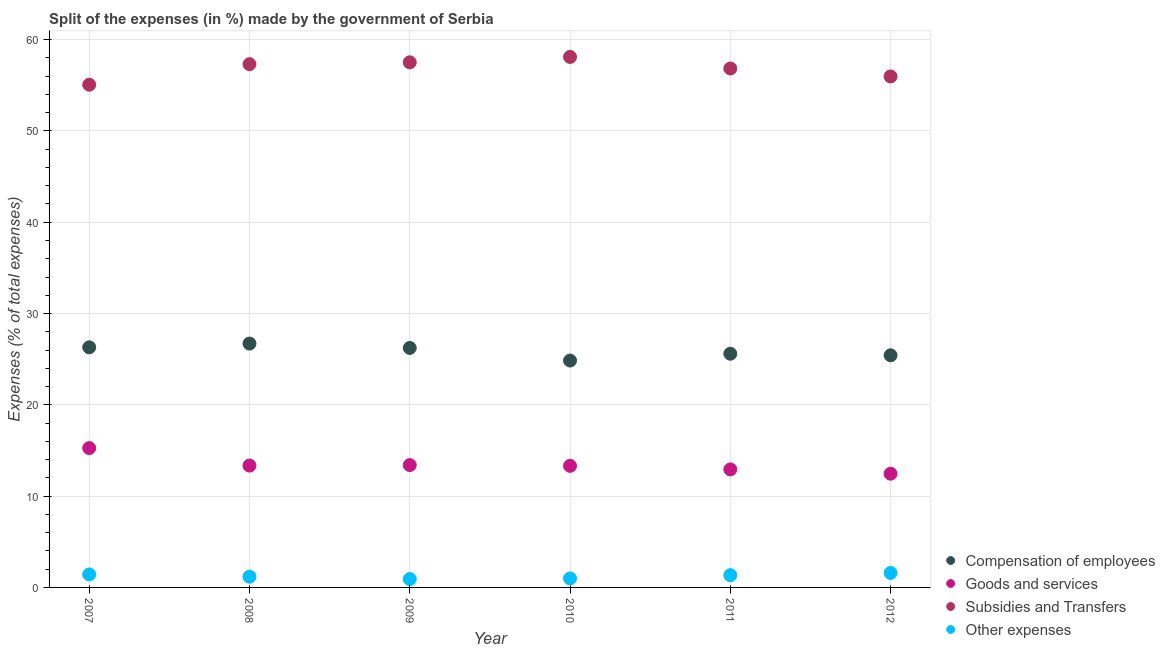How many different coloured dotlines are there?
Keep it short and to the point. 4. Is the number of dotlines equal to the number of legend labels?
Provide a short and direct response. Yes. What is the percentage of amount spent on subsidies in 2010?
Provide a short and direct response. 58.11. Across all years, what is the maximum percentage of amount spent on compensation of employees?
Your answer should be compact. 26.71. Across all years, what is the minimum percentage of amount spent on goods and services?
Make the answer very short. 12.46. In which year was the percentage of amount spent on goods and services minimum?
Give a very brief answer. 2012. What is the total percentage of amount spent on subsidies in the graph?
Keep it short and to the point. 340.81. What is the difference between the percentage of amount spent on subsidies in 2008 and that in 2011?
Your answer should be very brief. 0.48. What is the difference between the percentage of amount spent on subsidies in 2010 and the percentage of amount spent on goods and services in 2009?
Your response must be concise. 44.7. What is the average percentage of amount spent on subsidies per year?
Your answer should be compact. 56.8. In the year 2012, what is the difference between the percentage of amount spent on compensation of employees and percentage of amount spent on goods and services?
Ensure brevity in your answer.  12.97. In how many years, is the percentage of amount spent on goods and services greater than 26 %?
Keep it short and to the point. 0. What is the ratio of the percentage of amount spent on other expenses in 2009 to that in 2010?
Offer a very short reply. 0.93. Is the difference between the percentage of amount spent on compensation of employees in 2009 and 2012 greater than the difference between the percentage of amount spent on goods and services in 2009 and 2012?
Your answer should be compact. No. What is the difference between the highest and the second highest percentage of amount spent on other expenses?
Offer a terse response. 0.16. What is the difference between the highest and the lowest percentage of amount spent on compensation of employees?
Make the answer very short. 1.86. In how many years, is the percentage of amount spent on compensation of employees greater than the average percentage of amount spent on compensation of employees taken over all years?
Offer a terse response. 3. Is it the case that in every year, the sum of the percentage of amount spent on other expenses and percentage of amount spent on subsidies is greater than the sum of percentage of amount spent on goods and services and percentage of amount spent on compensation of employees?
Your answer should be very brief. Yes. Is it the case that in every year, the sum of the percentage of amount spent on compensation of employees and percentage of amount spent on goods and services is greater than the percentage of amount spent on subsidies?
Offer a very short reply. No. Is the percentage of amount spent on subsidies strictly greater than the percentage of amount spent on other expenses over the years?
Offer a terse response. Yes. Is the percentage of amount spent on compensation of employees strictly less than the percentage of amount spent on subsidies over the years?
Your answer should be very brief. Yes. How many years are there in the graph?
Offer a terse response. 6. What is the difference between two consecutive major ticks on the Y-axis?
Give a very brief answer. 10. Are the values on the major ticks of Y-axis written in scientific E-notation?
Ensure brevity in your answer.  No. Where does the legend appear in the graph?
Make the answer very short. Bottom right. How many legend labels are there?
Keep it short and to the point. 4. What is the title of the graph?
Your answer should be very brief. Split of the expenses (in %) made by the government of Serbia. What is the label or title of the X-axis?
Offer a very short reply. Year. What is the label or title of the Y-axis?
Make the answer very short. Expenses (% of total expenses). What is the Expenses (% of total expenses) of Compensation of employees in 2007?
Provide a short and direct response. 26.3. What is the Expenses (% of total expenses) in Goods and services in 2007?
Give a very brief answer. 15.26. What is the Expenses (% of total expenses) in Subsidies and Transfers in 2007?
Give a very brief answer. 55.06. What is the Expenses (% of total expenses) in Other expenses in 2007?
Keep it short and to the point. 1.42. What is the Expenses (% of total expenses) in Compensation of employees in 2008?
Your response must be concise. 26.71. What is the Expenses (% of total expenses) of Goods and services in 2008?
Give a very brief answer. 13.35. What is the Expenses (% of total expenses) of Subsidies and Transfers in 2008?
Give a very brief answer. 57.32. What is the Expenses (% of total expenses) in Other expenses in 2008?
Ensure brevity in your answer.  1.18. What is the Expenses (% of total expenses) in Compensation of employees in 2009?
Ensure brevity in your answer.  26.23. What is the Expenses (% of total expenses) in Goods and services in 2009?
Your answer should be very brief. 13.4. What is the Expenses (% of total expenses) of Subsidies and Transfers in 2009?
Keep it short and to the point. 57.52. What is the Expenses (% of total expenses) in Other expenses in 2009?
Make the answer very short. 0.92. What is the Expenses (% of total expenses) of Compensation of employees in 2010?
Keep it short and to the point. 24.85. What is the Expenses (% of total expenses) in Goods and services in 2010?
Your response must be concise. 13.32. What is the Expenses (% of total expenses) in Subsidies and Transfers in 2010?
Your response must be concise. 58.11. What is the Expenses (% of total expenses) in Other expenses in 2010?
Offer a very short reply. 0.99. What is the Expenses (% of total expenses) of Compensation of employees in 2011?
Make the answer very short. 25.6. What is the Expenses (% of total expenses) in Goods and services in 2011?
Your answer should be compact. 12.93. What is the Expenses (% of total expenses) in Subsidies and Transfers in 2011?
Keep it short and to the point. 56.84. What is the Expenses (% of total expenses) of Other expenses in 2011?
Provide a succinct answer. 1.34. What is the Expenses (% of total expenses) in Compensation of employees in 2012?
Your answer should be very brief. 25.43. What is the Expenses (% of total expenses) of Goods and services in 2012?
Keep it short and to the point. 12.46. What is the Expenses (% of total expenses) in Subsidies and Transfers in 2012?
Offer a terse response. 55.97. What is the Expenses (% of total expenses) in Other expenses in 2012?
Give a very brief answer. 1.59. Across all years, what is the maximum Expenses (% of total expenses) of Compensation of employees?
Your response must be concise. 26.71. Across all years, what is the maximum Expenses (% of total expenses) in Goods and services?
Your answer should be very brief. 15.26. Across all years, what is the maximum Expenses (% of total expenses) in Subsidies and Transfers?
Your answer should be very brief. 58.11. Across all years, what is the maximum Expenses (% of total expenses) of Other expenses?
Provide a short and direct response. 1.59. Across all years, what is the minimum Expenses (% of total expenses) in Compensation of employees?
Give a very brief answer. 24.85. Across all years, what is the minimum Expenses (% of total expenses) in Goods and services?
Offer a terse response. 12.46. Across all years, what is the minimum Expenses (% of total expenses) in Subsidies and Transfers?
Offer a terse response. 55.06. Across all years, what is the minimum Expenses (% of total expenses) of Other expenses?
Offer a very short reply. 0.92. What is the total Expenses (% of total expenses) of Compensation of employees in the graph?
Provide a short and direct response. 155.11. What is the total Expenses (% of total expenses) of Goods and services in the graph?
Your answer should be compact. 80.71. What is the total Expenses (% of total expenses) in Subsidies and Transfers in the graph?
Make the answer very short. 340.81. What is the total Expenses (% of total expenses) of Other expenses in the graph?
Provide a succinct answer. 7.43. What is the difference between the Expenses (% of total expenses) of Compensation of employees in 2007 and that in 2008?
Your answer should be compact. -0.41. What is the difference between the Expenses (% of total expenses) of Goods and services in 2007 and that in 2008?
Your answer should be compact. 1.92. What is the difference between the Expenses (% of total expenses) of Subsidies and Transfers in 2007 and that in 2008?
Offer a very short reply. -2.25. What is the difference between the Expenses (% of total expenses) of Other expenses in 2007 and that in 2008?
Give a very brief answer. 0.25. What is the difference between the Expenses (% of total expenses) of Compensation of employees in 2007 and that in 2009?
Provide a succinct answer. 0.07. What is the difference between the Expenses (% of total expenses) of Goods and services in 2007 and that in 2009?
Provide a short and direct response. 1.86. What is the difference between the Expenses (% of total expenses) of Subsidies and Transfers in 2007 and that in 2009?
Give a very brief answer. -2.45. What is the difference between the Expenses (% of total expenses) in Other expenses in 2007 and that in 2009?
Give a very brief answer. 0.5. What is the difference between the Expenses (% of total expenses) in Compensation of employees in 2007 and that in 2010?
Offer a terse response. 1.45. What is the difference between the Expenses (% of total expenses) of Goods and services in 2007 and that in 2010?
Your response must be concise. 1.94. What is the difference between the Expenses (% of total expenses) in Subsidies and Transfers in 2007 and that in 2010?
Your answer should be very brief. -3.04. What is the difference between the Expenses (% of total expenses) in Other expenses in 2007 and that in 2010?
Your response must be concise. 0.44. What is the difference between the Expenses (% of total expenses) of Compensation of employees in 2007 and that in 2011?
Offer a very short reply. 0.7. What is the difference between the Expenses (% of total expenses) of Goods and services in 2007 and that in 2011?
Your answer should be compact. 2.33. What is the difference between the Expenses (% of total expenses) in Subsidies and Transfers in 2007 and that in 2011?
Your response must be concise. -1.78. What is the difference between the Expenses (% of total expenses) of Other expenses in 2007 and that in 2011?
Ensure brevity in your answer.  0.08. What is the difference between the Expenses (% of total expenses) of Compensation of employees in 2007 and that in 2012?
Offer a very short reply. 0.87. What is the difference between the Expenses (% of total expenses) of Goods and services in 2007 and that in 2012?
Offer a terse response. 2.81. What is the difference between the Expenses (% of total expenses) of Subsidies and Transfers in 2007 and that in 2012?
Provide a succinct answer. -0.91. What is the difference between the Expenses (% of total expenses) in Other expenses in 2007 and that in 2012?
Your answer should be very brief. -0.16. What is the difference between the Expenses (% of total expenses) in Compensation of employees in 2008 and that in 2009?
Ensure brevity in your answer.  0.48. What is the difference between the Expenses (% of total expenses) in Goods and services in 2008 and that in 2009?
Keep it short and to the point. -0.06. What is the difference between the Expenses (% of total expenses) of Subsidies and Transfers in 2008 and that in 2009?
Make the answer very short. -0.2. What is the difference between the Expenses (% of total expenses) of Other expenses in 2008 and that in 2009?
Ensure brevity in your answer.  0.25. What is the difference between the Expenses (% of total expenses) in Compensation of employees in 2008 and that in 2010?
Make the answer very short. 1.86. What is the difference between the Expenses (% of total expenses) in Goods and services in 2008 and that in 2010?
Make the answer very short. 0.03. What is the difference between the Expenses (% of total expenses) of Subsidies and Transfers in 2008 and that in 2010?
Give a very brief answer. -0.79. What is the difference between the Expenses (% of total expenses) in Other expenses in 2008 and that in 2010?
Make the answer very short. 0.19. What is the difference between the Expenses (% of total expenses) in Compensation of employees in 2008 and that in 2011?
Provide a succinct answer. 1.11. What is the difference between the Expenses (% of total expenses) in Goods and services in 2008 and that in 2011?
Your answer should be compact. 0.42. What is the difference between the Expenses (% of total expenses) in Subsidies and Transfers in 2008 and that in 2011?
Provide a succinct answer. 0.48. What is the difference between the Expenses (% of total expenses) in Other expenses in 2008 and that in 2011?
Provide a short and direct response. -0.17. What is the difference between the Expenses (% of total expenses) of Compensation of employees in 2008 and that in 2012?
Your response must be concise. 1.28. What is the difference between the Expenses (% of total expenses) in Goods and services in 2008 and that in 2012?
Provide a succinct answer. 0.89. What is the difference between the Expenses (% of total expenses) of Subsidies and Transfers in 2008 and that in 2012?
Provide a succinct answer. 1.35. What is the difference between the Expenses (% of total expenses) of Other expenses in 2008 and that in 2012?
Your answer should be compact. -0.41. What is the difference between the Expenses (% of total expenses) of Compensation of employees in 2009 and that in 2010?
Give a very brief answer. 1.38. What is the difference between the Expenses (% of total expenses) of Goods and services in 2009 and that in 2010?
Ensure brevity in your answer.  0.08. What is the difference between the Expenses (% of total expenses) in Subsidies and Transfers in 2009 and that in 2010?
Make the answer very short. -0.59. What is the difference between the Expenses (% of total expenses) in Other expenses in 2009 and that in 2010?
Give a very brief answer. -0.07. What is the difference between the Expenses (% of total expenses) of Compensation of employees in 2009 and that in 2011?
Your answer should be very brief. 0.64. What is the difference between the Expenses (% of total expenses) in Goods and services in 2009 and that in 2011?
Your response must be concise. 0.47. What is the difference between the Expenses (% of total expenses) of Subsidies and Transfers in 2009 and that in 2011?
Ensure brevity in your answer.  0.68. What is the difference between the Expenses (% of total expenses) of Other expenses in 2009 and that in 2011?
Your response must be concise. -0.42. What is the difference between the Expenses (% of total expenses) of Compensation of employees in 2009 and that in 2012?
Ensure brevity in your answer.  0.81. What is the difference between the Expenses (% of total expenses) of Goods and services in 2009 and that in 2012?
Provide a short and direct response. 0.95. What is the difference between the Expenses (% of total expenses) in Subsidies and Transfers in 2009 and that in 2012?
Your response must be concise. 1.55. What is the difference between the Expenses (% of total expenses) of Other expenses in 2009 and that in 2012?
Your response must be concise. -0.67. What is the difference between the Expenses (% of total expenses) in Compensation of employees in 2010 and that in 2011?
Your answer should be very brief. -0.75. What is the difference between the Expenses (% of total expenses) in Goods and services in 2010 and that in 2011?
Ensure brevity in your answer.  0.39. What is the difference between the Expenses (% of total expenses) of Subsidies and Transfers in 2010 and that in 2011?
Your response must be concise. 1.27. What is the difference between the Expenses (% of total expenses) of Other expenses in 2010 and that in 2011?
Give a very brief answer. -0.36. What is the difference between the Expenses (% of total expenses) in Compensation of employees in 2010 and that in 2012?
Keep it short and to the point. -0.58. What is the difference between the Expenses (% of total expenses) of Goods and services in 2010 and that in 2012?
Offer a very short reply. 0.86. What is the difference between the Expenses (% of total expenses) of Subsidies and Transfers in 2010 and that in 2012?
Offer a very short reply. 2.14. What is the difference between the Expenses (% of total expenses) in Compensation of employees in 2011 and that in 2012?
Your answer should be very brief. 0.17. What is the difference between the Expenses (% of total expenses) of Goods and services in 2011 and that in 2012?
Provide a succinct answer. 0.47. What is the difference between the Expenses (% of total expenses) in Subsidies and Transfers in 2011 and that in 2012?
Make the answer very short. 0.87. What is the difference between the Expenses (% of total expenses) of Other expenses in 2011 and that in 2012?
Provide a succinct answer. -0.24. What is the difference between the Expenses (% of total expenses) in Compensation of employees in 2007 and the Expenses (% of total expenses) in Goods and services in 2008?
Keep it short and to the point. 12.95. What is the difference between the Expenses (% of total expenses) in Compensation of employees in 2007 and the Expenses (% of total expenses) in Subsidies and Transfers in 2008?
Provide a short and direct response. -31.02. What is the difference between the Expenses (% of total expenses) of Compensation of employees in 2007 and the Expenses (% of total expenses) of Other expenses in 2008?
Give a very brief answer. 25.12. What is the difference between the Expenses (% of total expenses) of Goods and services in 2007 and the Expenses (% of total expenses) of Subsidies and Transfers in 2008?
Make the answer very short. -42.05. What is the difference between the Expenses (% of total expenses) in Goods and services in 2007 and the Expenses (% of total expenses) in Other expenses in 2008?
Your answer should be very brief. 14.09. What is the difference between the Expenses (% of total expenses) of Subsidies and Transfers in 2007 and the Expenses (% of total expenses) of Other expenses in 2008?
Keep it short and to the point. 53.89. What is the difference between the Expenses (% of total expenses) of Compensation of employees in 2007 and the Expenses (% of total expenses) of Goods and services in 2009?
Ensure brevity in your answer.  12.9. What is the difference between the Expenses (% of total expenses) in Compensation of employees in 2007 and the Expenses (% of total expenses) in Subsidies and Transfers in 2009?
Make the answer very short. -31.22. What is the difference between the Expenses (% of total expenses) of Compensation of employees in 2007 and the Expenses (% of total expenses) of Other expenses in 2009?
Make the answer very short. 25.38. What is the difference between the Expenses (% of total expenses) in Goods and services in 2007 and the Expenses (% of total expenses) in Subsidies and Transfers in 2009?
Offer a very short reply. -42.25. What is the difference between the Expenses (% of total expenses) of Goods and services in 2007 and the Expenses (% of total expenses) of Other expenses in 2009?
Offer a terse response. 14.34. What is the difference between the Expenses (% of total expenses) of Subsidies and Transfers in 2007 and the Expenses (% of total expenses) of Other expenses in 2009?
Offer a terse response. 54.14. What is the difference between the Expenses (% of total expenses) in Compensation of employees in 2007 and the Expenses (% of total expenses) in Goods and services in 2010?
Offer a terse response. 12.98. What is the difference between the Expenses (% of total expenses) of Compensation of employees in 2007 and the Expenses (% of total expenses) of Subsidies and Transfers in 2010?
Provide a succinct answer. -31.81. What is the difference between the Expenses (% of total expenses) in Compensation of employees in 2007 and the Expenses (% of total expenses) in Other expenses in 2010?
Offer a terse response. 25.31. What is the difference between the Expenses (% of total expenses) of Goods and services in 2007 and the Expenses (% of total expenses) of Subsidies and Transfers in 2010?
Provide a succinct answer. -42.84. What is the difference between the Expenses (% of total expenses) in Goods and services in 2007 and the Expenses (% of total expenses) in Other expenses in 2010?
Make the answer very short. 14.28. What is the difference between the Expenses (% of total expenses) of Subsidies and Transfers in 2007 and the Expenses (% of total expenses) of Other expenses in 2010?
Make the answer very short. 54.08. What is the difference between the Expenses (% of total expenses) of Compensation of employees in 2007 and the Expenses (% of total expenses) of Goods and services in 2011?
Provide a succinct answer. 13.37. What is the difference between the Expenses (% of total expenses) in Compensation of employees in 2007 and the Expenses (% of total expenses) in Subsidies and Transfers in 2011?
Your answer should be compact. -30.54. What is the difference between the Expenses (% of total expenses) of Compensation of employees in 2007 and the Expenses (% of total expenses) of Other expenses in 2011?
Give a very brief answer. 24.96. What is the difference between the Expenses (% of total expenses) of Goods and services in 2007 and the Expenses (% of total expenses) of Subsidies and Transfers in 2011?
Keep it short and to the point. -41.58. What is the difference between the Expenses (% of total expenses) of Goods and services in 2007 and the Expenses (% of total expenses) of Other expenses in 2011?
Your answer should be very brief. 13.92. What is the difference between the Expenses (% of total expenses) of Subsidies and Transfers in 2007 and the Expenses (% of total expenses) of Other expenses in 2011?
Offer a terse response. 53.72. What is the difference between the Expenses (% of total expenses) of Compensation of employees in 2007 and the Expenses (% of total expenses) of Goods and services in 2012?
Your answer should be very brief. 13.84. What is the difference between the Expenses (% of total expenses) of Compensation of employees in 2007 and the Expenses (% of total expenses) of Subsidies and Transfers in 2012?
Make the answer very short. -29.67. What is the difference between the Expenses (% of total expenses) in Compensation of employees in 2007 and the Expenses (% of total expenses) in Other expenses in 2012?
Provide a succinct answer. 24.71. What is the difference between the Expenses (% of total expenses) of Goods and services in 2007 and the Expenses (% of total expenses) of Subsidies and Transfers in 2012?
Offer a very short reply. -40.71. What is the difference between the Expenses (% of total expenses) in Goods and services in 2007 and the Expenses (% of total expenses) in Other expenses in 2012?
Offer a very short reply. 13.68. What is the difference between the Expenses (% of total expenses) in Subsidies and Transfers in 2007 and the Expenses (% of total expenses) in Other expenses in 2012?
Offer a very short reply. 53.48. What is the difference between the Expenses (% of total expenses) in Compensation of employees in 2008 and the Expenses (% of total expenses) in Goods and services in 2009?
Offer a very short reply. 13.31. What is the difference between the Expenses (% of total expenses) of Compensation of employees in 2008 and the Expenses (% of total expenses) of Subsidies and Transfers in 2009?
Your answer should be very brief. -30.81. What is the difference between the Expenses (% of total expenses) in Compensation of employees in 2008 and the Expenses (% of total expenses) in Other expenses in 2009?
Provide a short and direct response. 25.79. What is the difference between the Expenses (% of total expenses) of Goods and services in 2008 and the Expenses (% of total expenses) of Subsidies and Transfers in 2009?
Offer a terse response. -44.17. What is the difference between the Expenses (% of total expenses) of Goods and services in 2008 and the Expenses (% of total expenses) of Other expenses in 2009?
Your answer should be very brief. 12.43. What is the difference between the Expenses (% of total expenses) of Subsidies and Transfers in 2008 and the Expenses (% of total expenses) of Other expenses in 2009?
Keep it short and to the point. 56.4. What is the difference between the Expenses (% of total expenses) in Compensation of employees in 2008 and the Expenses (% of total expenses) in Goods and services in 2010?
Offer a terse response. 13.39. What is the difference between the Expenses (% of total expenses) in Compensation of employees in 2008 and the Expenses (% of total expenses) in Subsidies and Transfers in 2010?
Your answer should be very brief. -31.4. What is the difference between the Expenses (% of total expenses) in Compensation of employees in 2008 and the Expenses (% of total expenses) in Other expenses in 2010?
Ensure brevity in your answer.  25.72. What is the difference between the Expenses (% of total expenses) of Goods and services in 2008 and the Expenses (% of total expenses) of Subsidies and Transfers in 2010?
Your answer should be very brief. -44.76. What is the difference between the Expenses (% of total expenses) of Goods and services in 2008 and the Expenses (% of total expenses) of Other expenses in 2010?
Offer a terse response. 12.36. What is the difference between the Expenses (% of total expenses) of Subsidies and Transfers in 2008 and the Expenses (% of total expenses) of Other expenses in 2010?
Your answer should be very brief. 56.33. What is the difference between the Expenses (% of total expenses) of Compensation of employees in 2008 and the Expenses (% of total expenses) of Goods and services in 2011?
Offer a very short reply. 13.78. What is the difference between the Expenses (% of total expenses) of Compensation of employees in 2008 and the Expenses (% of total expenses) of Subsidies and Transfers in 2011?
Your response must be concise. -30.13. What is the difference between the Expenses (% of total expenses) in Compensation of employees in 2008 and the Expenses (% of total expenses) in Other expenses in 2011?
Provide a succinct answer. 25.37. What is the difference between the Expenses (% of total expenses) in Goods and services in 2008 and the Expenses (% of total expenses) in Subsidies and Transfers in 2011?
Provide a succinct answer. -43.49. What is the difference between the Expenses (% of total expenses) in Goods and services in 2008 and the Expenses (% of total expenses) in Other expenses in 2011?
Your answer should be compact. 12. What is the difference between the Expenses (% of total expenses) in Subsidies and Transfers in 2008 and the Expenses (% of total expenses) in Other expenses in 2011?
Make the answer very short. 55.97. What is the difference between the Expenses (% of total expenses) of Compensation of employees in 2008 and the Expenses (% of total expenses) of Goods and services in 2012?
Provide a succinct answer. 14.25. What is the difference between the Expenses (% of total expenses) of Compensation of employees in 2008 and the Expenses (% of total expenses) of Subsidies and Transfers in 2012?
Your response must be concise. -29.26. What is the difference between the Expenses (% of total expenses) in Compensation of employees in 2008 and the Expenses (% of total expenses) in Other expenses in 2012?
Make the answer very short. 25.12. What is the difference between the Expenses (% of total expenses) in Goods and services in 2008 and the Expenses (% of total expenses) in Subsidies and Transfers in 2012?
Ensure brevity in your answer.  -42.62. What is the difference between the Expenses (% of total expenses) in Goods and services in 2008 and the Expenses (% of total expenses) in Other expenses in 2012?
Your response must be concise. 11.76. What is the difference between the Expenses (% of total expenses) of Subsidies and Transfers in 2008 and the Expenses (% of total expenses) of Other expenses in 2012?
Your response must be concise. 55.73. What is the difference between the Expenses (% of total expenses) in Compensation of employees in 2009 and the Expenses (% of total expenses) in Goods and services in 2010?
Give a very brief answer. 12.91. What is the difference between the Expenses (% of total expenses) in Compensation of employees in 2009 and the Expenses (% of total expenses) in Subsidies and Transfers in 2010?
Your response must be concise. -31.87. What is the difference between the Expenses (% of total expenses) in Compensation of employees in 2009 and the Expenses (% of total expenses) in Other expenses in 2010?
Provide a short and direct response. 25.25. What is the difference between the Expenses (% of total expenses) in Goods and services in 2009 and the Expenses (% of total expenses) in Subsidies and Transfers in 2010?
Give a very brief answer. -44.7. What is the difference between the Expenses (% of total expenses) in Goods and services in 2009 and the Expenses (% of total expenses) in Other expenses in 2010?
Ensure brevity in your answer.  12.42. What is the difference between the Expenses (% of total expenses) of Subsidies and Transfers in 2009 and the Expenses (% of total expenses) of Other expenses in 2010?
Keep it short and to the point. 56.53. What is the difference between the Expenses (% of total expenses) of Compensation of employees in 2009 and the Expenses (% of total expenses) of Goods and services in 2011?
Give a very brief answer. 13.3. What is the difference between the Expenses (% of total expenses) in Compensation of employees in 2009 and the Expenses (% of total expenses) in Subsidies and Transfers in 2011?
Your answer should be very brief. -30.61. What is the difference between the Expenses (% of total expenses) in Compensation of employees in 2009 and the Expenses (% of total expenses) in Other expenses in 2011?
Ensure brevity in your answer.  24.89. What is the difference between the Expenses (% of total expenses) in Goods and services in 2009 and the Expenses (% of total expenses) in Subsidies and Transfers in 2011?
Keep it short and to the point. -43.44. What is the difference between the Expenses (% of total expenses) of Goods and services in 2009 and the Expenses (% of total expenses) of Other expenses in 2011?
Offer a very short reply. 12.06. What is the difference between the Expenses (% of total expenses) of Subsidies and Transfers in 2009 and the Expenses (% of total expenses) of Other expenses in 2011?
Provide a succinct answer. 56.17. What is the difference between the Expenses (% of total expenses) in Compensation of employees in 2009 and the Expenses (% of total expenses) in Goods and services in 2012?
Keep it short and to the point. 13.78. What is the difference between the Expenses (% of total expenses) in Compensation of employees in 2009 and the Expenses (% of total expenses) in Subsidies and Transfers in 2012?
Your answer should be compact. -29.74. What is the difference between the Expenses (% of total expenses) of Compensation of employees in 2009 and the Expenses (% of total expenses) of Other expenses in 2012?
Your answer should be very brief. 24.65. What is the difference between the Expenses (% of total expenses) in Goods and services in 2009 and the Expenses (% of total expenses) in Subsidies and Transfers in 2012?
Provide a short and direct response. -42.57. What is the difference between the Expenses (% of total expenses) of Goods and services in 2009 and the Expenses (% of total expenses) of Other expenses in 2012?
Your answer should be very brief. 11.82. What is the difference between the Expenses (% of total expenses) in Subsidies and Transfers in 2009 and the Expenses (% of total expenses) in Other expenses in 2012?
Your answer should be compact. 55.93. What is the difference between the Expenses (% of total expenses) in Compensation of employees in 2010 and the Expenses (% of total expenses) in Goods and services in 2011?
Your answer should be very brief. 11.92. What is the difference between the Expenses (% of total expenses) of Compensation of employees in 2010 and the Expenses (% of total expenses) of Subsidies and Transfers in 2011?
Give a very brief answer. -31.99. What is the difference between the Expenses (% of total expenses) of Compensation of employees in 2010 and the Expenses (% of total expenses) of Other expenses in 2011?
Make the answer very short. 23.51. What is the difference between the Expenses (% of total expenses) of Goods and services in 2010 and the Expenses (% of total expenses) of Subsidies and Transfers in 2011?
Give a very brief answer. -43.52. What is the difference between the Expenses (% of total expenses) of Goods and services in 2010 and the Expenses (% of total expenses) of Other expenses in 2011?
Your answer should be compact. 11.98. What is the difference between the Expenses (% of total expenses) of Subsidies and Transfers in 2010 and the Expenses (% of total expenses) of Other expenses in 2011?
Give a very brief answer. 56.76. What is the difference between the Expenses (% of total expenses) in Compensation of employees in 2010 and the Expenses (% of total expenses) in Goods and services in 2012?
Your answer should be compact. 12.39. What is the difference between the Expenses (% of total expenses) in Compensation of employees in 2010 and the Expenses (% of total expenses) in Subsidies and Transfers in 2012?
Give a very brief answer. -31.12. What is the difference between the Expenses (% of total expenses) in Compensation of employees in 2010 and the Expenses (% of total expenses) in Other expenses in 2012?
Provide a short and direct response. 23.26. What is the difference between the Expenses (% of total expenses) of Goods and services in 2010 and the Expenses (% of total expenses) of Subsidies and Transfers in 2012?
Provide a succinct answer. -42.65. What is the difference between the Expenses (% of total expenses) in Goods and services in 2010 and the Expenses (% of total expenses) in Other expenses in 2012?
Ensure brevity in your answer.  11.73. What is the difference between the Expenses (% of total expenses) of Subsidies and Transfers in 2010 and the Expenses (% of total expenses) of Other expenses in 2012?
Your answer should be compact. 56.52. What is the difference between the Expenses (% of total expenses) in Compensation of employees in 2011 and the Expenses (% of total expenses) in Goods and services in 2012?
Your response must be concise. 13.14. What is the difference between the Expenses (% of total expenses) of Compensation of employees in 2011 and the Expenses (% of total expenses) of Subsidies and Transfers in 2012?
Make the answer very short. -30.37. What is the difference between the Expenses (% of total expenses) of Compensation of employees in 2011 and the Expenses (% of total expenses) of Other expenses in 2012?
Give a very brief answer. 24.01. What is the difference between the Expenses (% of total expenses) of Goods and services in 2011 and the Expenses (% of total expenses) of Subsidies and Transfers in 2012?
Provide a succinct answer. -43.04. What is the difference between the Expenses (% of total expenses) in Goods and services in 2011 and the Expenses (% of total expenses) in Other expenses in 2012?
Your answer should be compact. 11.34. What is the difference between the Expenses (% of total expenses) in Subsidies and Transfers in 2011 and the Expenses (% of total expenses) in Other expenses in 2012?
Give a very brief answer. 55.25. What is the average Expenses (% of total expenses) in Compensation of employees per year?
Your answer should be very brief. 25.85. What is the average Expenses (% of total expenses) of Goods and services per year?
Your answer should be very brief. 13.45. What is the average Expenses (% of total expenses) in Subsidies and Transfers per year?
Your answer should be compact. 56.8. What is the average Expenses (% of total expenses) in Other expenses per year?
Your answer should be very brief. 1.24. In the year 2007, what is the difference between the Expenses (% of total expenses) in Compensation of employees and Expenses (% of total expenses) in Goods and services?
Your response must be concise. 11.04. In the year 2007, what is the difference between the Expenses (% of total expenses) of Compensation of employees and Expenses (% of total expenses) of Subsidies and Transfers?
Give a very brief answer. -28.76. In the year 2007, what is the difference between the Expenses (% of total expenses) of Compensation of employees and Expenses (% of total expenses) of Other expenses?
Make the answer very short. 24.88. In the year 2007, what is the difference between the Expenses (% of total expenses) in Goods and services and Expenses (% of total expenses) in Subsidies and Transfers?
Give a very brief answer. -39.8. In the year 2007, what is the difference between the Expenses (% of total expenses) in Goods and services and Expenses (% of total expenses) in Other expenses?
Ensure brevity in your answer.  13.84. In the year 2007, what is the difference between the Expenses (% of total expenses) in Subsidies and Transfers and Expenses (% of total expenses) in Other expenses?
Your response must be concise. 53.64. In the year 2008, what is the difference between the Expenses (% of total expenses) in Compensation of employees and Expenses (% of total expenses) in Goods and services?
Your response must be concise. 13.36. In the year 2008, what is the difference between the Expenses (% of total expenses) of Compensation of employees and Expenses (% of total expenses) of Subsidies and Transfers?
Keep it short and to the point. -30.61. In the year 2008, what is the difference between the Expenses (% of total expenses) in Compensation of employees and Expenses (% of total expenses) in Other expenses?
Keep it short and to the point. 25.53. In the year 2008, what is the difference between the Expenses (% of total expenses) in Goods and services and Expenses (% of total expenses) in Subsidies and Transfers?
Make the answer very short. -43.97. In the year 2008, what is the difference between the Expenses (% of total expenses) in Goods and services and Expenses (% of total expenses) in Other expenses?
Make the answer very short. 12.17. In the year 2008, what is the difference between the Expenses (% of total expenses) in Subsidies and Transfers and Expenses (% of total expenses) in Other expenses?
Your response must be concise. 56.14. In the year 2009, what is the difference between the Expenses (% of total expenses) in Compensation of employees and Expenses (% of total expenses) in Goods and services?
Offer a terse response. 12.83. In the year 2009, what is the difference between the Expenses (% of total expenses) in Compensation of employees and Expenses (% of total expenses) in Subsidies and Transfers?
Provide a succinct answer. -31.28. In the year 2009, what is the difference between the Expenses (% of total expenses) of Compensation of employees and Expenses (% of total expenses) of Other expenses?
Your answer should be very brief. 25.31. In the year 2009, what is the difference between the Expenses (% of total expenses) in Goods and services and Expenses (% of total expenses) in Subsidies and Transfers?
Provide a short and direct response. -44.11. In the year 2009, what is the difference between the Expenses (% of total expenses) in Goods and services and Expenses (% of total expenses) in Other expenses?
Ensure brevity in your answer.  12.48. In the year 2009, what is the difference between the Expenses (% of total expenses) of Subsidies and Transfers and Expenses (% of total expenses) of Other expenses?
Offer a very short reply. 56.59. In the year 2010, what is the difference between the Expenses (% of total expenses) in Compensation of employees and Expenses (% of total expenses) in Goods and services?
Ensure brevity in your answer.  11.53. In the year 2010, what is the difference between the Expenses (% of total expenses) in Compensation of employees and Expenses (% of total expenses) in Subsidies and Transfers?
Offer a very short reply. -33.26. In the year 2010, what is the difference between the Expenses (% of total expenses) of Compensation of employees and Expenses (% of total expenses) of Other expenses?
Give a very brief answer. 23.86. In the year 2010, what is the difference between the Expenses (% of total expenses) in Goods and services and Expenses (% of total expenses) in Subsidies and Transfers?
Keep it short and to the point. -44.79. In the year 2010, what is the difference between the Expenses (% of total expenses) of Goods and services and Expenses (% of total expenses) of Other expenses?
Provide a succinct answer. 12.33. In the year 2010, what is the difference between the Expenses (% of total expenses) of Subsidies and Transfers and Expenses (% of total expenses) of Other expenses?
Provide a short and direct response. 57.12. In the year 2011, what is the difference between the Expenses (% of total expenses) in Compensation of employees and Expenses (% of total expenses) in Goods and services?
Your answer should be very brief. 12.67. In the year 2011, what is the difference between the Expenses (% of total expenses) of Compensation of employees and Expenses (% of total expenses) of Subsidies and Transfers?
Your answer should be very brief. -31.24. In the year 2011, what is the difference between the Expenses (% of total expenses) of Compensation of employees and Expenses (% of total expenses) of Other expenses?
Keep it short and to the point. 24.25. In the year 2011, what is the difference between the Expenses (% of total expenses) in Goods and services and Expenses (% of total expenses) in Subsidies and Transfers?
Your response must be concise. -43.91. In the year 2011, what is the difference between the Expenses (% of total expenses) in Goods and services and Expenses (% of total expenses) in Other expenses?
Offer a terse response. 11.59. In the year 2011, what is the difference between the Expenses (% of total expenses) in Subsidies and Transfers and Expenses (% of total expenses) in Other expenses?
Ensure brevity in your answer.  55.5. In the year 2012, what is the difference between the Expenses (% of total expenses) of Compensation of employees and Expenses (% of total expenses) of Goods and services?
Keep it short and to the point. 12.97. In the year 2012, what is the difference between the Expenses (% of total expenses) in Compensation of employees and Expenses (% of total expenses) in Subsidies and Transfers?
Your response must be concise. -30.54. In the year 2012, what is the difference between the Expenses (% of total expenses) in Compensation of employees and Expenses (% of total expenses) in Other expenses?
Offer a terse response. 23.84. In the year 2012, what is the difference between the Expenses (% of total expenses) in Goods and services and Expenses (% of total expenses) in Subsidies and Transfers?
Ensure brevity in your answer.  -43.51. In the year 2012, what is the difference between the Expenses (% of total expenses) of Goods and services and Expenses (% of total expenses) of Other expenses?
Keep it short and to the point. 10.87. In the year 2012, what is the difference between the Expenses (% of total expenses) of Subsidies and Transfers and Expenses (% of total expenses) of Other expenses?
Offer a terse response. 54.38. What is the ratio of the Expenses (% of total expenses) in Compensation of employees in 2007 to that in 2008?
Your response must be concise. 0.98. What is the ratio of the Expenses (% of total expenses) of Goods and services in 2007 to that in 2008?
Your answer should be compact. 1.14. What is the ratio of the Expenses (% of total expenses) of Subsidies and Transfers in 2007 to that in 2008?
Your answer should be very brief. 0.96. What is the ratio of the Expenses (% of total expenses) in Other expenses in 2007 to that in 2008?
Your answer should be compact. 1.21. What is the ratio of the Expenses (% of total expenses) of Goods and services in 2007 to that in 2009?
Ensure brevity in your answer.  1.14. What is the ratio of the Expenses (% of total expenses) of Subsidies and Transfers in 2007 to that in 2009?
Provide a succinct answer. 0.96. What is the ratio of the Expenses (% of total expenses) in Other expenses in 2007 to that in 2009?
Provide a succinct answer. 1.54. What is the ratio of the Expenses (% of total expenses) in Compensation of employees in 2007 to that in 2010?
Offer a terse response. 1.06. What is the ratio of the Expenses (% of total expenses) in Goods and services in 2007 to that in 2010?
Your response must be concise. 1.15. What is the ratio of the Expenses (% of total expenses) in Subsidies and Transfers in 2007 to that in 2010?
Your response must be concise. 0.95. What is the ratio of the Expenses (% of total expenses) in Other expenses in 2007 to that in 2010?
Your answer should be very brief. 1.44. What is the ratio of the Expenses (% of total expenses) of Compensation of employees in 2007 to that in 2011?
Offer a very short reply. 1.03. What is the ratio of the Expenses (% of total expenses) of Goods and services in 2007 to that in 2011?
Provide a succinct answer. 1.18. What is the ratio of the Expenses (% of total expenses) in Subsidies and Transfers in 2007 to that in 2011?
Offer a terse response. 0.97. What is the ratio of the Expenses (% of total expenses) in Other expenses in 2007 to that in 2011?
Keep it short and to the point. 1.06. What is the ratio of the Expenses (% of total expenses) of Compensation of employees in 2007 to that in 2012?
Your answer should be compact. 1.03. What is the ratio of the Expenses (% of total expenses) in Goods and services in 2007 to that in 2012?
Make the answer very short. 1.23. What is the ratio of the Expenses (% of total expenses) in Subsidies and Transfers in 2007 to that in 2012?
Ensure brevity in your answer.  0.98. What is the ratio of the Expenses (% of total expenses) of Other expenses in 2007 to that in 2012?
Give a very brief answer. 0.9. What is the ratio of the Expenses (% of total expenses) of Compensation of employees in 2008 to that in 2009?
Offer a terse response. 1.02. What is the ratio of the Expenses (% of total expenses) of Goods and services in 2008 to that in 2009?
Provide a succinct answer. 1. What is the ratio of the Expenses (% of total expenses) of Other expenses in 2008 to that in 2009?
Keep it short and to the point. 1.28. What is the ratio of the Expenses (% of total expenses) of Compensation of employees in 2008 to that in 2010?
Provide a succinct answer. 1.07. What is the ratio of the Expenses (% of total expenses) in Goods and services in 2008 to that in 2010?
Make the answer very short. 1. What is the ratio of the Expenses (% of total expenses) in Subsidies and Transfers in 2008 to that in 2010?
Provide a short and direct response. 0.99. What is the ratio of the Expenses (% of total expenses) of Other expenses in 2008 to that in 2010?
Keep it short and to the point. 1.19. What is the ratio of the Expenses (% of total expenses) of Compensation of employees in 2008 to that in 2011?
Your answer should be compact. 1.04. What is the ratio of the Expenses (% of total expenses) of Goods and services in 2008 to that in 2011?
Offer a terse response. 1.03. What is the ratio of the Expenses (% of total expenses) in Subsidies and Transfers in 2008 to that in 2011?
Keep it short and to the point. 1.01. What is the ratio of the Expenses (% of total expenses) of Other expenses in 2008 to that in 2011?
Your answer should be compact. 0.88. What is the ratio of the Expenses (% of total expenses) of Compensation of employees in 2008 to that in 2012?
Your answer should be compact. 1.05. What is the ratio of the Expenses (% of total expenses) in Goods and services in 2008 to that in 2012?
Give a very brief answer. 1.07. What is the ratio of the Expenses (% of total expenses) of Subsidies and Transfers in 2008 to that in 2012?
Make the answer very short. 1.02. What is the ratio of the Expenses (% of total expenses) in Other expenses in 2008 to that in 2012?
Your answer should be compact. 0.74. What is the ratio of the Expenses (% of total expenses) of Compensation of employees in 2009 to that in 2010?
Give a very brief answer. 1.06. What is the ratio of the Expenses (% of total expenses) of Subsidies and Transfers in 2009 to that in 2010?
Provide a succinct answer. 0.99. What is the ratio of the Expenses (% of total expenses) of Other expenses in 2009 to that in 2010?
Offer a terse response. 0.93. What is the ratio of the Expenses (% of total expenses) in Compensation of employees in 2009 to that in 2011?
Your answer should be compact. 1.02. What is the ratio of the Expenses (% of total expenses) in Goods and services in 2009 to that in 2011?
Provide a succinct answer. 1.04. What is the ratio of the Expenses (% of total expenses) in Subsidies and Transfers in 2009 to that in 2011?
Provide a succinct answer. 1.01. What is the ratio of the Expenses (% of total expenses) in Other expenses in 2009 to that in 2011?
Your response must be concise. 0.69. What is the ratio of the Expenses (% of total expenses) of Compensation of employees in 2009 to that in 2012?
Make the answer very short. 1.03. What is the ratio of the Expenses (% of total expenses) in Goods and services in 2009 to that in 2012?
Keep it short and to the point. 1.08. What is the ratio of the Expenses (% of total expenses) in Subsidies and Transfers in 2009 to that in 2012?
Make the answer very short. 1.03. What is the ratio of the Expenses (% of total expenses) of Other expenses in 2009 to that in 2012?
Ensure brevity in your answer.  0.58. What is the ratio of the Expenses (% of total expenses) in Compensation of employees in 2010 to that in 2011?
Your response must be concise. 0.97. What is the ratio of the Expenses (% of total expenses) in Goods and services in 2010 to that in 2011?
Make the answer very short. 1.03. What is the ratio of the Expenses (% of total expenses) of Subsidies and Transfers in 2010 to that in 2011?
Provide a short and direct response. 1.02. What is the ratio of the Expenses (% of total expenses) of Other expenses in 2010 to that in 2011?
Offer a terse response. 0.73. What is the ratio of the Expenses (% of total expenses) of Compensation of employees in 2010 to that in 2012?
Ensure brevity in your answer.  0.98. What is the ratio of the Expenses (% of total expenses) in Goods and services in 2010 to that in 2012?
Your response must be concise. 1.07. What is the ratio of the Expenses (% of total expenses) in Subsidies and Transfers in 2010 to that in 2012?
Offer a terse response. 1.04. What is the ratio of the Expenses (% of total expenses) in Other expenses in 2010 to that in 2012?
Your response must be concise. 0.62. What is the ratio of the Expenses (% of total expenses) in Goods and services in 2011 to that in 2012?
Keep it short and to the point. 1.04. What is the ratio of the Expenses (% of total expenses) of Subsidies and Transfers in 2011 to that in 2012?
Offer a terse response. 1.02. What is the ratio of the Expenses (% of total expenses) in Other expenses in 2011 to that in 2012?
Give a very brief answer. 0.85. What is the difference between the highest and the second highest Expenses (% of total expenses) in Compensation of employees?
Make the answer very short. 0.41. What is the difference between the highest and the second highest Expenses (% of total expenses) of Goods and services?
Make the answer very short. 1.86. What is the difference between the highest and the second highest Expenses (% of total expenses) in Subsidies and Transfers?
Make the answer very short. 0.59. What is the difference between the highest and the second highest Expenses (% of total expenses) in Other expenses?
Ensure brevity in your answer.  0.16. What is the difference between the highest and the lowest Expenses (% of total expenses) of Compensation of employees?
Ensure brevity in your answer.  1.86. What is the difference between the highest and the lowest Expenses (% of total expenses) of Goods and services?
Offer a terse response. 2.81. What is the difference between the highest and the lowest Expenses (% of total expenses) of Subsidies and Transfers?
Make the answer very short. 3.04. What is the difference between the highest and the lowest Expenses (% of total expenses) in Other expenses?
Offer a very short reply. 0.67. 